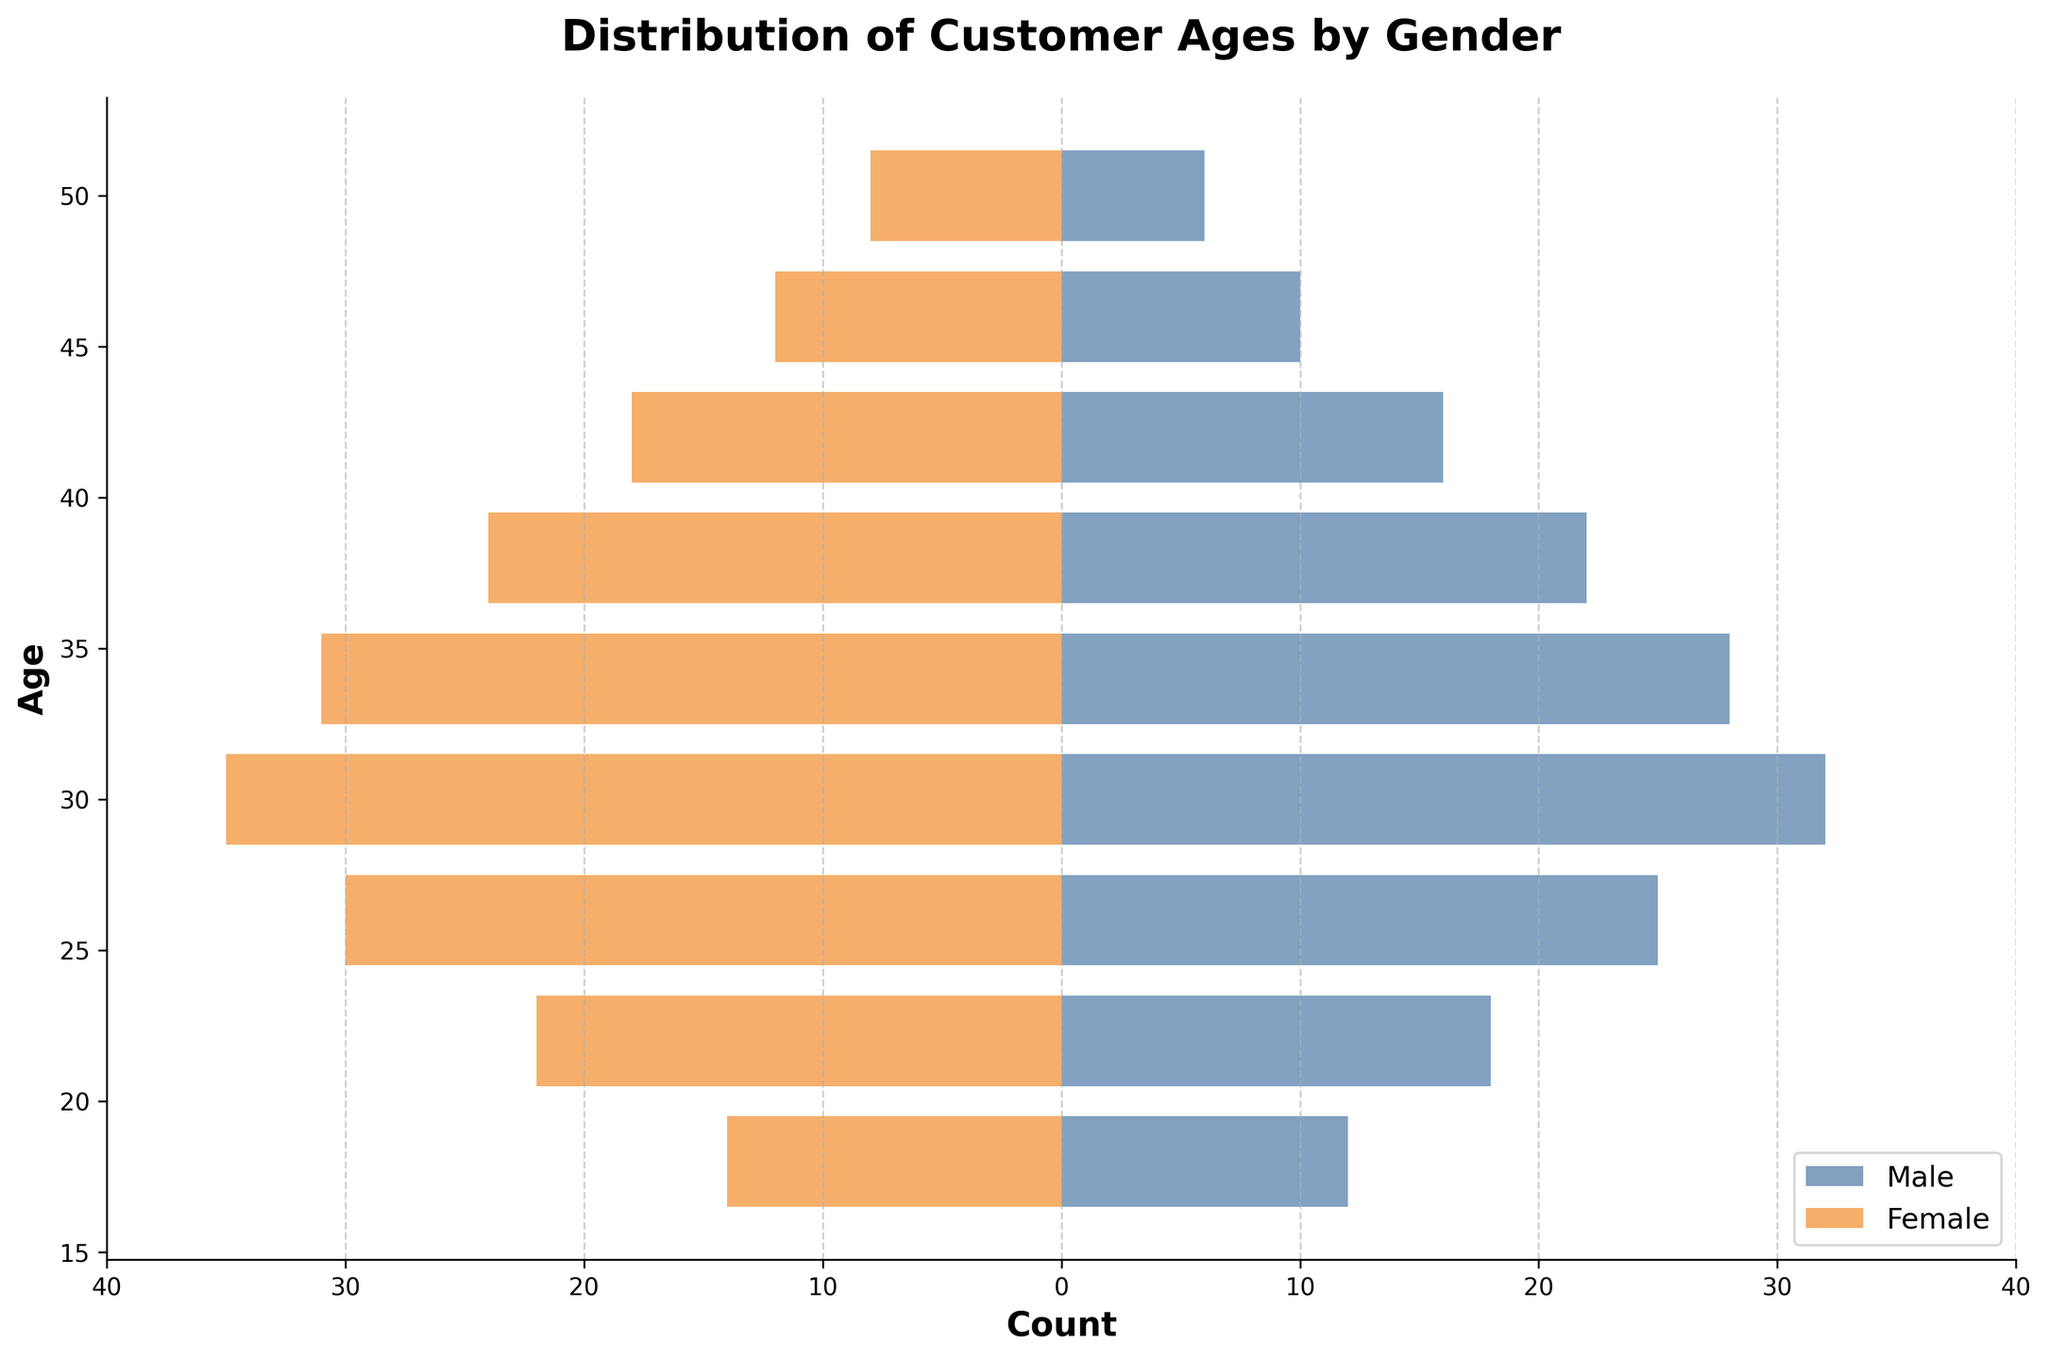What is the title of the plot? The title of the plot is usually located at the top and describes what the figure represents. In this case, it reads "Distribution of Customer Ages by Gender".
Answer: Distribution of Customer Ages by Gender What are the labels on the x-axis? The x-axis labels indicate the count of customers by age, and it shows numbers from -40 to 40. The negative counts on the left are for females, and the positive counts on the right are for males.
Answer: Count Which age group has the highest count for males? By observing the positive bars representing males, the age group with the longest bar is 30.
Answer: 30 Which age group has the lowest count for females? By observing the negative bars representing females, the age group with the shortest bar is 50.
Answer: 50 What is the overall trend for both genders in terms of age distribution? The overall trend shows that for both genders, customer count peaks around the age of 30 and gradually decreases as age increases or decreases from there.
Answer: Peaks around age 30 Which gender has more customers in the 34 age group? By comparing the absolute lengths of the bars at age 34, females have a slightly longer bar to the left, indicating a higher count.
Answer: Female What's the total count difference between males and females in the 26 age group? For males, the count at age 26 is 25, and for females, it's 30. Subtracting the male count from the female count gives 30 - 25 = 5.
Answer: 5 Is there any age group where the number of male customers is equal to the female customers? By examining the bars, there is no age group where the lengths of the bars for males and females are the same.
Answer: No What is the cumulative count of customers aged 50 for both genders? The count for males aged 50 is 6, and for females, it is 8. Adding these gives 6 + 8 = 14.
Answer: 14 